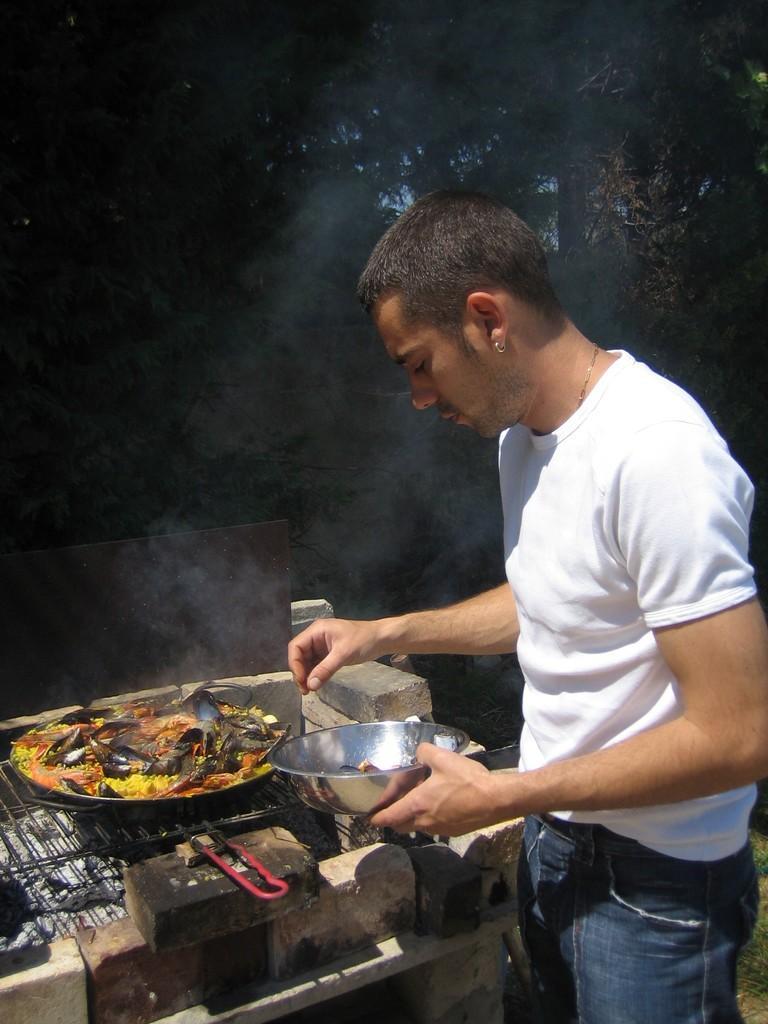How would you summarize this image in a sentence or two? In this image I can see a person standing wearing white shirt, blue pant. In front I can see food in the pan. Background I can see trees, and sky in blue color. 